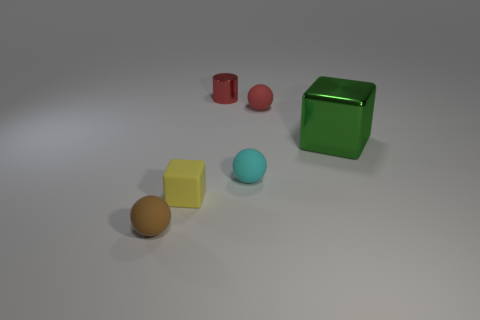Add 2 red metallic cylinders. How many objects exist? 8 Subtract all purple spheres. Subtract all red blocks. How many spheres are left? 3 Subtract all cubes. How many objects are left? 4 Add 4 tiny cyan spheres. How many tiny cyan spheres are left? 5 Add 5 small cyan rubber balls. How many small cyan rubber balls exist? 6 Subtract 0 purple cylinders. How many objects are left? 6 Subtract all green blocks. Subtract all yellow things. How many objects are left? 4 